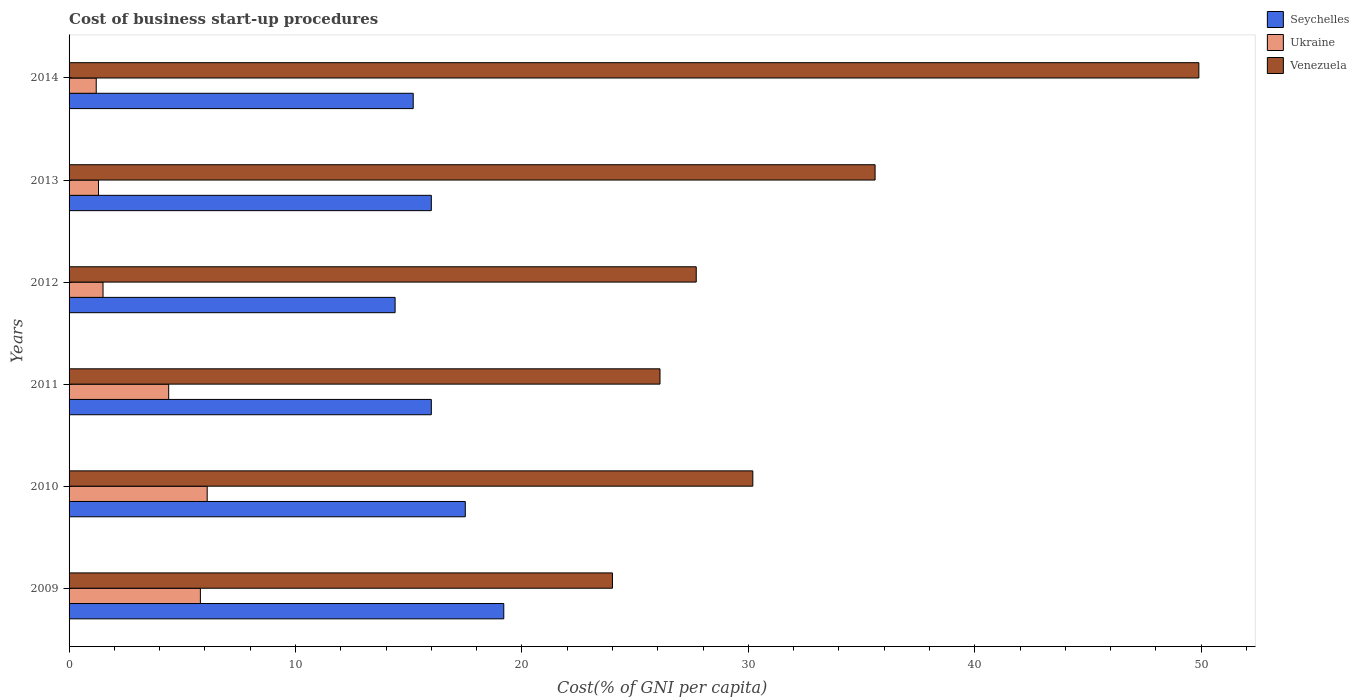Are the number of bars per tick equal to the number of legend labels?
Offer a very short reply. Yes. How many bars are there on the 6th tick from the bottom?
Your answer should be compact. 3. What is the label of the 6th group of bars from the top?
Keep it short and to the point. 2009. In how many cases, is the number of bars for a given year not equal to the number of legend labels?
Give a very brief answer. 0. What is the cost of business start-up procedures in Venezuela in 2014?
Give a very brief answer. 49.9. In which year was the cost of business start-up procedures in Ukraine maximum?
Keep it short and to the point. 2010. In which year was the cost of business start-up procedures in Ukraine minimum?
Provide a succinct answer. 2014. What is the total cost of business start-up procedures in Ukraine in the graph?
Ensure brevity in your answer.  20.3. What is the difference between the cost of business start-up procedures in Seychelles in 2010 and that in 2014?
Your answer should be compact. 2.3. What is the difference between the cost of business start-up procedures in Seychelles in 2013 and the cost of business start-up procedures in Ukraine in 2012?
Provide a succinct answer. 14.5. What is the average cost of business start-up procedures in Seychelles per year?
Your answer should be compact. 16.38. In the year 2012, what is the difference between the cost of business start-up procedures in Venezuela and cost of business start-up procedures in Seychelles?
Provide a succinct answer. 13.3. What is the ratio of the cost of business start-up procedures in Seychelles in 2011 to that in 2012?
Keep it short and to the point. 1.11. Is the difference between the cost of business start-up procedures in Venezuela in 2011 and 2012 greater than the difference between the cost of business start-up procedures in Seychelles in 2011 and 2012?
Ensure brevity in your answer.  No. What is the difference between the highest and the second highest cost of business start-up procedures in Seychelles?
Offer a very short reply. 1.7. What is the difference between the highest and the lowest cost of business start-up procedures in Seychelles?
Ensure brevity in your answer.  4.8. In how many years, is the cost of business start-up procedures in Venezuela greater than the average cost of business start-up procedures in Venezuela taken over all years?
Your answer should be compact. 2. Is the sum of the cost of business start-up procedures in Venezuela in 2012 and 2014 greater than the maximum cost of business start-up procedures in Seychelles across all years?
Give a very brief answer. Yes. What does the 2nd bar from the top in 2009 represents?
Make the answer very short. Ukraine. What does the 2nd bar from the bottom in 2010 represents?
Keep it short and to the point. Ukraine. How many bars are there?
Give a very brief answer. 18. Are all the bars in the graph horizontal?
Keep it short and to the point. Yes. How many years are there in the graph?
Offer a terse response. 6. What is the difference between two consecutive major ticks on the X-axis?
Your answer should be compact. 10. How many legend labels are there?
Provide a succinct answer. 3. What is the title of the graph?
Keep it short and to the point. Cost of business start-up procedures. Does "Samoa" appear as one of the legend labels in the graph?
Make the answer very short. No. What is the label or title of the X-axis?
Your answer should be compact. Cost(% of GNI per capita). What is the label or title of the Y-axis?
Make the answer very short. Years. What is the Cost(% of GNI per capita) in Seychelles in 2009?
Your response must be concise. 19.2. What is the Cost(% of GNI per capita) in Venezuela in 2009?
Make the answer very short. 24. What is the Cost(% of GNI per capita) of Ukraine in 2010?
Offer a very short reply. 6.1. What is the Cost(% of GNI per capita) in Venezuela in 2010?
Give a very brief answer. 30.2. What is the Cost(% of GNI per capita) of Seychelles in 2011?
Provide a succinct answer. 16. What is the Cost(% of GNI per capita) of Ukraine in 2011?
Your response must be concise. 4.4. What is the Cost(% of GNI per capita) of Venezuela in 2011?
Provide a short and direct response. 26.1. What is the Cost(% of GNI per capita) of Venezuela in 2012?
Make the answer very short. 27.7. What is the Cost(% of GNI per capita) of Seychelles in 2013?
Your response must be concise. 16. What is the Cost(% of GNI per capita) in Venezuela in 2013?
Provide a short and direct response. 35.6. What is the Cost(% of GNI per capita) in Venezuela in 2014?
Your response must be concise. 49.9. Across all years, what is the maximum Cost(% of GNI per capita) in Ukraine?
Your answer should be compact. 6.1. Across all years, what is the maximum Cost(% of GNI per capita) of Venezuela?
Ensure brevity in your answer.  49.9. Across all years, what is the minimum Cost(% of GNI per capita) of Seychelles?
Your answer should be very brief. 14.4. What is the total Cost(% of GNI per capita) of Seychelles in the graph?
Provide a succinct answer. 98.3. What is the total Cost(% of GNI per capita) in Ukraine in the graph?
Make the answer very short. 20.3. What is the total Cost(% of GNI per capita) in Venezuela in the graph?
Offer a very short reply. 193.5. What is the difference between the Cost(% of GNI per capita) of Seychelles in 2009 and that in 2010?
Your response must be concise. 1.7. What is the difference between the Cost(% of GNI per capita) of Ukraine in 2009 and that in 2010?
Offer a very short reply. -0.3. What is the difference between the Cost(% of GNI per capita) in Seychelles in 2009 and that in 2012?
Your answer should be very brief. 4.8. What is the difference between the Cost(% of GNI per capita) in Ukraine in 2009 and that in 2012?
Make the answer very short. 4.3. What is the difference between the Cost(% of GNI per capita) of Ukraine in 2009 and that in 2013?
Ensure brevity in your answer.  4.5. What is the difference between the Cost(% of GNI per capita) of Ukraine in 2009 and that in 2014?
Make the answer very short. 4.6. What is the difference between the Cost(% of GNI per capita) in Venezuela in 2009 and that in 2014?
Keep it short and to the point. -25.9. What is the difference between the Cost(% of GNI per capita) in Ukraine in 2010 and that in 2011?
Your answer should be very brief. 1.7. What is the difference between the Cost(% of GNI per capita) of Seychelles in 2010 and that in 2012?
Make the answer very short. 3.1. What is the difference between the Cost(% of GNI per capita) of Venezuela in 2010 and that in 2012?
Provide a succinct answer. 2.5. What is the difference between the Cost(% of GNI per capita) in Seychelles in 2010 and that in 2013?
Ensure brevity in your answer.  1.5. What is the difference between the Cost(% of GNI per capita) of Ukraine in 2010 and that in 2014?
Give a very brief answer. 4.9. What is the difference between the Cost(% of GNI per capita) of Venezuela in 2010 and that in 2014?
Offer a terse response. -19.7. What is the difference between the Cost(% of GNI per capita) in Ukraine in 2011 and that in 2012?
Keep it short and to the point. 2.9. What is the difference between the Cost(% of GNI per capita) of Seychelles in 2011 and that in 2013?
Provide a short and direct response. 0. What is the difference between the Cost(% of GNI per capita) of Venezuela in 2011 and that in 2014?
Your answer should be compact. -23.8. What is the difference between the Cost(% of GNI per capita) in Ukraine in 2012 and that in 2013?
Ensure brevity in your answer.  0.2. What is the difference between the Cost(% of GNI per capita) in Venezuela in 2012 and that in 2013?
Make the answer very short. -7.9. What is the difference between the Cost(% of GNI per capita) in Seychelles in 2012 and that in 2014?
Your answer should be very brief. -0.8. What is the difference between the Cost(% of GNI per capita) in Ukraine in 2012 and that in 2014?
Give a very brief answer. 0.3. What is the difference between the Cost(% of GNI per capita) of Venezuela in 2012 and that in 2014?
Give a very brief answer. -22.2. What is the difference between the Cost(% of GNI per capita) of Seychelles in 2013 and that in 2014?
Offer a very short reply. 0.8. What is the difference between the Cost(% of GNI per capita) of Venezuela in 2013 and that in 2014?
Keep it short and to the point. -14.3. What is the difference between the Cost(% of GNI per capita) in Ukraine in 2009 and the Cost(% of GNI per capita) in Venezuela in 2010?
Offer a terse response. -24.4. What is the difference between the Cost(% of GNI per capita) in Seychelles in 2009 and the Cost(% of GNI per capita) in Ukraine in 2011?
Ensure brevity in your answer.  14.8. What is the difference between the Cost(% of GNI per capita) of Seychelles in 2009 and the Cost(% of GNI per capita) of Venezuela in 2011?
Your answer should be compact. -6.9. What is the difference between the Cost(% of GNI per capita) of Ukraine in 2009 and the Cost(% of GNI per capita) of Venezuela in 2011?
Give a very brief answer. -20.3. What is the difference between the Cost(% of GNI per capita) of Ukraine in 2009 and the Cost(% of GNI per capita) of Venezuela in 2012?
Provide a succinct answer. -21.9. What is the difference between the Cost(% of GNI per capita) in Seychelles in 2009 and the Cost(% of GNI per capita) in Venezuela in 2013?
Provide a succinct answer. -16.4. What is the difference between the Cost(% of GNI per capita) in Ukraine in 2009 and the Cost(% of GNI per capita) in Venezuela in 2013?
Your answer should be very brief. -29.8. What is the difference between the Cost(% of GNI per capita) in Seychelles in 2009 and the Cost(% of GNI per capita) in Venezuela in 2014?
Provide a short and direct response. -30.7. What is the difference between the Cost(% of GNI per capita) in Ukraine in 2009 and the Cost(% of GNI per capita) in Venezuela in 2014?
Give a very brief answer. -44.1. What is the difference between the Cost(% of GNI per capita) of Seychelles in 2010 and the Cost(% of GNI per capita) of Ukraine in 2011?
Your answer should be very brief. 13.1. What is the difference between the Cost(% of GNI per capita) of Seychelles in 2010 and the Cost(% of GNI per capita) of Ukraine in 2012?
Ensure brevity in your answer.  16. What is the difference between the Cost(% of GNI per capita) of Seychelles in 2010 and the Cost(% of GNI per capita) of Venezuela in 2012?
Provide a succinct answer. -10.2. What is the difference between the Cost(% of GNI per capita) in Ukraine in 2010 and the Cost(% of GNI per capita) in Venezuela in 2012?
Provide a short and direct response. -21.6. What is the difference between the Cost(% of GNI per capita) in Seychelles in 2010 and the Cost(% of GNI per capita) in Venezuela in 2013?
Make the answer very short. -18.1. What is the difference between the Cost(% of GNI per capita) in Ukraine in 2010 and the Cost(% of GNI per capita) in Venezuela in 2013?
Keep it short and to the point. -29.5. What is the difference between the Cost(% of GNI per capita) in Seychelles in 2010 and the Cost(% of GNI per capita) in Venezuela in 2014?
Give a very brief answer. -32.4. What is the difference between the Cost(% of GNI per capita) in Ukraine in 2010 and the Cost(% of GNI per capita) in Venezuela in 2014?
Provide a short and direct response. -43.8. What is the difference between the Cost(% of GNI per capita) in Seychelles in 2011 and the Cost(% of GNI per capita) in Ukraine in 2012?
Your answer should be very brief. 14.5. What is the difference between the Cost(% of GNI per capita) of Ukraine in 2011 and the Cost(% of GNI per capita) of Venezuela in 2012?
Provide a short and direct response. -23.3. What is the difference between the Cost(% of GNI per capita) in Seychelles in 2011 and the Cost(% of GNI per capita) in Ukraine in 2013?
Make the answer very short. 14.7. What is the difference between the Cost(% of GNI per capita) of Seychelles in 2011 and the Cost(% of GNI per capita) of Venezuela in 2013?
Your answer should be very brief. -19.6. What is the difference between the Cost(% of GNI per capita) in Ukraine in 2011 and the Cost(% of GNI per capita) in Venezuela in 2013?
Provide a succinct answer. -31.2. What is the difference between the Cost(% of GNI per capita) of Seychelles in 2011 and the Cost(% of GNI per capita) of Venezuela in 2014?
Provide a succinct answer. -33.9. What is the difference between the Cost(% of GNI per capita) in Ukraine in 2011 and the Cost(% of GNI per capita) in Venezuela in 2014?
Give a very brief answer. -45.5. What is the difference between the Cost(% of GNI per capita) of Seychelles in 2012 and the Cost(% of GNI per capita) of Ukraine in 2013?
Give a very brief answer. 13.1. What is the difference between the Cost(% of GNI per capita) in Seychelles in 2012 and the Cost(% of GNI per capita) in Venezuela in 2013?
Ensure brevity in your answer.  -21.2. What is the difference between the Cost(% of GNI per capita) in Ukraine in 2012 and the Cost(% of GNI per capita) in Venezuela in 2013?
Make the answer very short. -34.1. What is the difference between the Cost(% of GNI per capita) of Seychelles in 2012 and the Cost(% of GNI per capita) of Ukraine in 2014?
Make the answer very short. 13.2. What is the difference between the Cost(% of GNI per capita) in Seychelles in 2012 and the Cost(% of GNI per capita) in Venezuela in 2014?
Keep it short and to the point. -35.5. What is the difference between the Cost(% of GNI per capita) in Ukraine in 2012 and the Cost(% of GNI per capita) in Venezuela in 2014?
Provide a short and direct response. -48.4. What is the difference between the Cost(% of GNI per capita) of Seychelles in 2013 and the Cost(% of GNI per capita) of Ukraine in 2014?
Your response must be concise. 14.8. What is the difference between the Cost(% of GNI per capita) in Seychelles in 2013 and the Cost(% of GNI per capita) in Venezuela in 2014?
Provide a succinct answer. -33.9. What is the difference between the Cost(% of GNI per capita) of Ukraine in 2013 and the Cost(% of GNI per capita) of Venezuela in 2014?
Make the answer very short. -48.6. What is the average Cost(% of GNI per capita) in Seychelles per year?
Provide a succinct answer. 16.38. What is the average Cost(% of GNI per capita) of Ukraine per year?
Offer a terse response. 3.38. What is the average Cost(% of GNI per capita) of Venezuela per year?
Offer a terse response. 32.25. In the year 2009, what is the difference between the Cost(% of GNI per capita) in Seychelles and Cost(% of GNI per capita) in Ukraine?
Provide a succinct answer. 13.4. In the year 2009, what is the difference between the Cost(% of GNI per capita) in Seychelles and Cost(% of GNI per capita) in Venezuela?
Ensure brevity in your answer.  -4.8. In the year 2009, what is the difference between the Cost(% of GNI per capita) of Ukraine and Cost(% of GNI per capita) of Venezuela?
Make the answer very short. -18.2. In the year 2010, what is the difference between the Cost(% of GNI per capita) of Seychelles and Cost(% of GNI per capita) of Ukraine?
Offer a very short reply. 11.4. In the year 2010, what is the difference between the Cost(% of GNI per capita) in Ukraine and Cost(% of GNI per capita) in Venezuela?
Keep it short and to the point. -24.1. In the year 2011, what is the difference between the Cost(% of GNI per capita) of Seychelles and Cost(% of GNI per capita) of Ukraine?
Your response must be concise. 11.6. In the year 2011, what is the difference between the Cost(% of GNI per capita) in Seychelles and Cost(% of GNI per capita) in Venezuela?
Your answer should be very brief. -10.1. In the year 2011, what is the difference between the Cost(% of GNI per capita) of Ukraine and Cost(% of GNI per capita) of Venezuela?
Give a very brief answer. -21.7. In the year 2012, what is the difference between the Cost(% of GNI per capita) in Ukraine and Cost(% of GNI per capita) in Venezuela?
Offer a very short reply. -26.2. In the year 2013, what is the difference between the Cost(% of GNI per capita) of Seychelles and Cost(% of GNI per capita) of Venezuela?
Offer a very short reply. -19.6. In the year 2013, what is the difference between the Cost(% of GNI per capita) of Ukraine and Cost(% of GNI per capita) of Venezuela?
Offer a very short reply. -34.3. In the year 2014, what is the difference between the Cost(% of GNI per capita) of Seychelles and Cost(% of GNI per capita) of Venezuela?
Provide a succinct answer. -34.7. In the year 2014, what is the difference between the Cost(% of GNI per capita) in Ukraine and Cost(% of GNI per capita) in Venezuela?
Give a very brief answer. -48.7. What is the ratio of the Cost(% of GNI per capita) in Seychelles in 2009 to that in 2010?
Your answer should be very brief. 1.1. What is the ratio of the Cost(% of GNI per capita) in Ukraine in 2009 to that in 2010?
Provide a succinct answer. 0.95. What is the ratio of the Cost(% of GNI per capita) in Venezuela in 2009 to that in 2010?
Ensure brevity in your answer.  0.79. What is the ratio of the Cost(% of GNI per capita) in Ukraine in 2009 to that in 2011?
Make the answer very short. 1.32. What is the ratio of the Cost(% of GNI per capita) of Venezuela in 2009 to that in 2011?
Ensure brevity in your answer.  0.92. What is the ratio of the Cost(% of GNI per capita) of Seychelles in 2009 to that in 2012?
Give a very brief answer. 1.33. What is the ratio of the Cost(% of GNI per capita) in Ukraine in 2009 to that in 2012?
Ensure brevity in your answer.  3.87. What is the ratio of the Cost(% of GNI per capita) in Venezuela in 2009 to that in 2012?
Offer a terse response. 0.87. What is the ratio of the Cost(% of GNI per capita) in Seychelles in 2009 to that in 2013?
Provide a short and direct response. 1.2. What is the ratio of the Cost(% of GNI per capita) in Ukraine in 2009 to that in 2013?
Give a very brief answer. 4.46. What is the ratio of the Cost(% of GNI per capita) in Venezuela in 2009 to that in 2013?
Your answer should be very brief. 0.67. What is the ratio of the Cost(% of GNI per capita) of Seychelles in 2009 to that in 2014?
Make the answer very short. 1.26. What is the ratio of the Cost(% of GNI per capita) in Ukraine in 2009 to that in 2014?
Your answer should be compact. 4.83. What is the ratio of the Cost(% of GNI per capita) of Venezuela in 2009 to that in 2014?
Give a very brief answer. 0.48. What is the ratio of the Cost(% of GNI per capita) of Seychelles in 2010 to that in 2011?
Your response must be concise. 1.09. What is the ratio of the Cost(% of GNI per capita) in Ukraine in 2010 to that in 2011?
Provide a succinct answer. 1.39. What is the ratio of the Cost(% of GNI per capita) in Venezuela in 2010 to that in 2011?
Provide a succinct answer. 1.16. What is the ratio of the Cost(% of GNI per capita) of Seychelles in 2010 to that in 2012?
Provide a short and direct response. 1.22. What is the ratio of the Cost(% of GNI per capita) of Ukraine in 2010 to that in 2012?
Provide a succinct answer. 4.07. What is the ratio of the Cost(% of GNI per capita) of Venezuela in 2010 to that in 2012?
Give a very brief answer. 1.09. What is the ratio of the Cost(% of GNI per capita) in Seychelles in 2010 to that in 2013?
Your answer should be compact. 1.09. What is the ratio of the Cost(% of GNI per capita) in Ukraine in 2010 to that in 2013?
Offer a terse response. 4.69. What is the ratio of the Cost(% of GNI per capita) of Venezuela in 2010 to that in 2013?
Offer a very short reply. 0.85. What is the ratio of the Cost(% of GNI per capita) in Seychelles in 2010 to that in 2014?
Ensure brevity in your answer.  1.15. What is the ratio of the Cost(% of GNI per capita) of Ukraine in 2010 to that in 2014?
Your response must be concise. 5.08. What is the ratio of the Cost(% of GNI per capita) in Venezuela in 2010 to that in 2014?
Keep it short and to the point. 0.61. What is the ratio of the Cost(% of GNI per capita) in Ukraine in 2011 to that in 2012?
Your response must be concise. 2.93. What is the ratio of the Cost(% of GNI per capita) of Venezuela in 2011 to that in 2012?
Provide a short and direct response. 0.94. What is the ratio of the Cost(% of GNI per capita) of Ukraine in 2011 to that in 2013?
Provide a succinct answer. 3.38. What is the ratio of the Cost(% of GNI per capita) in Venezuela in 2011 to that in 2013?
Offer a terse response. 0.73. What is the ratio of the Cost(% of GNI per capita) of Seychelles in 2011 to that in 2014?
Offer a very short reply. 1.05. What is the ratio of the Cost(% of GNI per capita) in Ukraine in 2011 to that in 2014?
Give a very brief answer. 3.67. What is the ratio of the Cost(% of GNI per capita) in Venezuela in 2011 to that in 2014?
Give a very brief answer. 0.52. What is the ratio of the Cost(% of GNI per capita) in Ukraine in 2012 to that in 2013?
Your answer should be compact. 1.15. What is the ratio of the Cost(% of GNI per capita) of Venezuela in 2012 to that in 2013?
Provide a short and direct response. 0.78. What is the ratio of the Cost(% of GNI per capita) in Ukraine in 2012 to that in 2014?
Offer a terse response. 1.25. What is the ratio of the Cost(% of GNI per capita) of Venezuela in 2012 to that in 2014?
Offer a terse response. 0.56. What is the ratio of the Cost(% of GNI per capita) in Seychelles in 2013 to that in 2014?
Your answer should be compact. 1.05. What is the ratio of the Cost(% of GNI per capita) in Venezuela in 2013 to that in 2014?
Your answer should be compact. 0.71. What is the difference between the highest and the second highest Cost(% of GNI per capita) in Ukraine?
Your answer should be very brief. 0.3. What is the difference between the highest and the second highest Cost(% of GNI per capita) of Venezuela?
Offer a terse response. 14.3. What is the difference between the highest and the lowest Cost(% of GNI per capita) of Venezuela?
Ensure brevity in your answer.  25.9. 